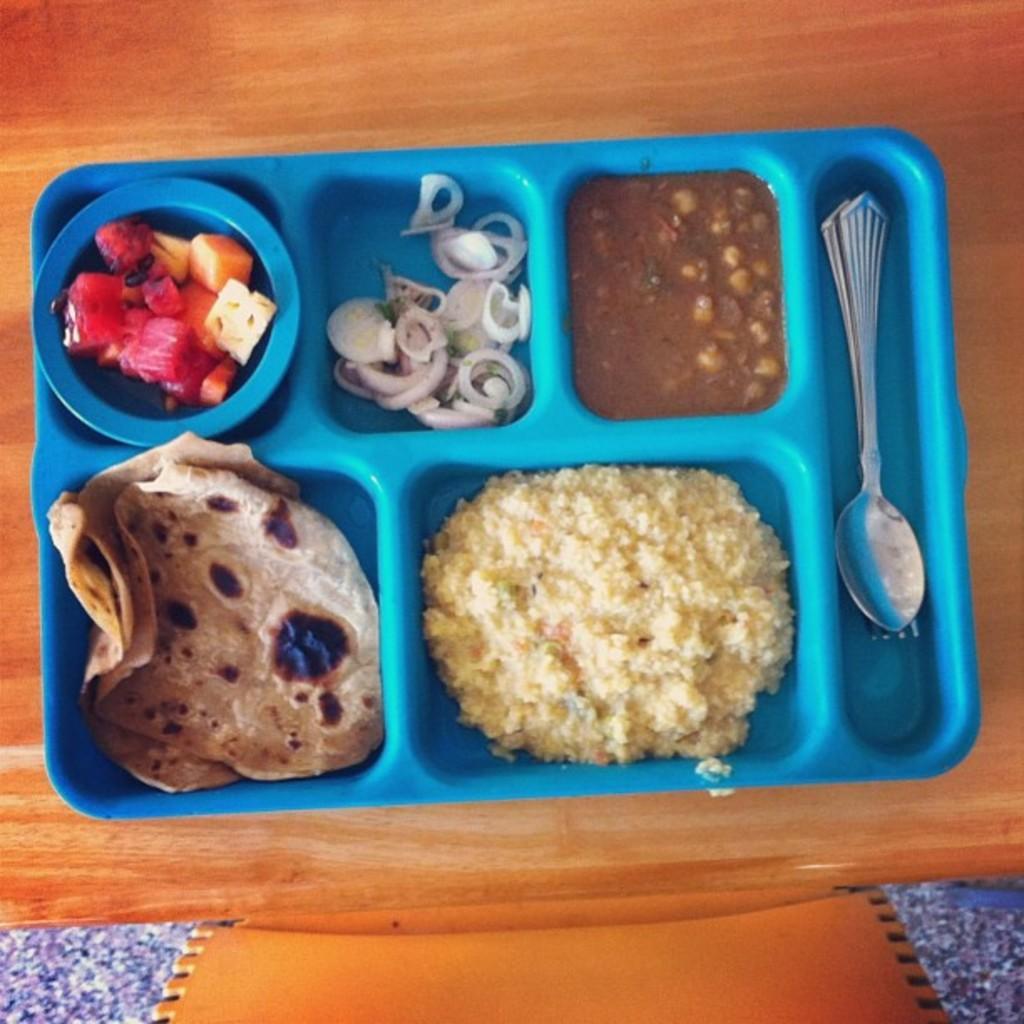Please provide a concise description of this image. In this picture, we see a blue plate containing the chapatis, chopped onions, rice, curry and a spoon is placed on the table. We even see a bowl containing the chopped fruits is paced in the plate. At the bottom, we see an orange chair and the cloth in blue color. 